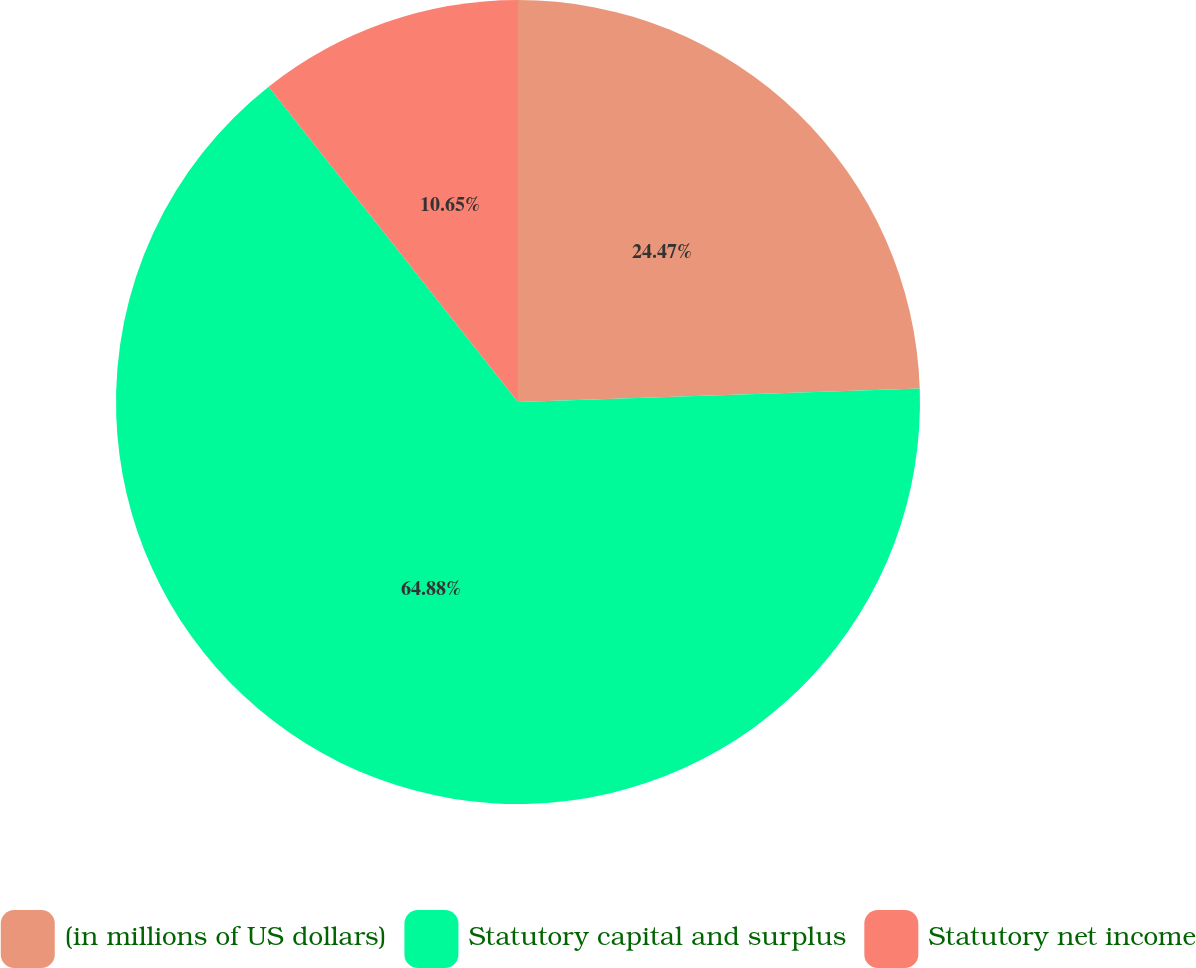Convert chart to OTSL. <chart><loc_0><loc_0><loc_500><loc_500><pie_chart><fcel>(in millions of US dollars)<fcel>Statutory capital and surplus<fcel>Statutory net income<nl><fcel>24.47%<fcel>64.88%<fcel>10.65%<nl></chart> 